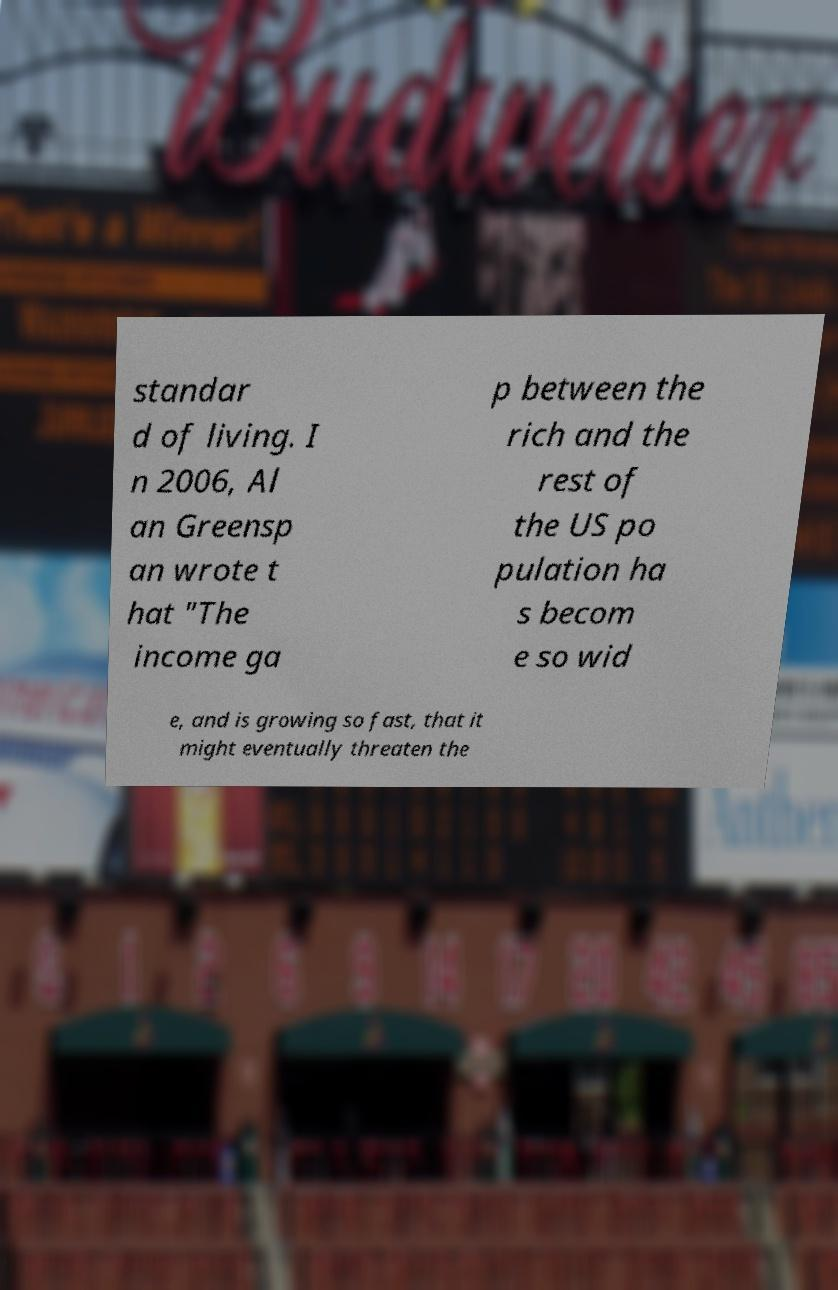Could you assist in decoding the text presented in this image and type it out clearly? standar d of living. I n 2006, Al an Greensp an wrote t hat "The income ga p between the rich and the rest of the US po pulation ha s becom e so wid e, and is growing so fast, that it might eventually threaten the 